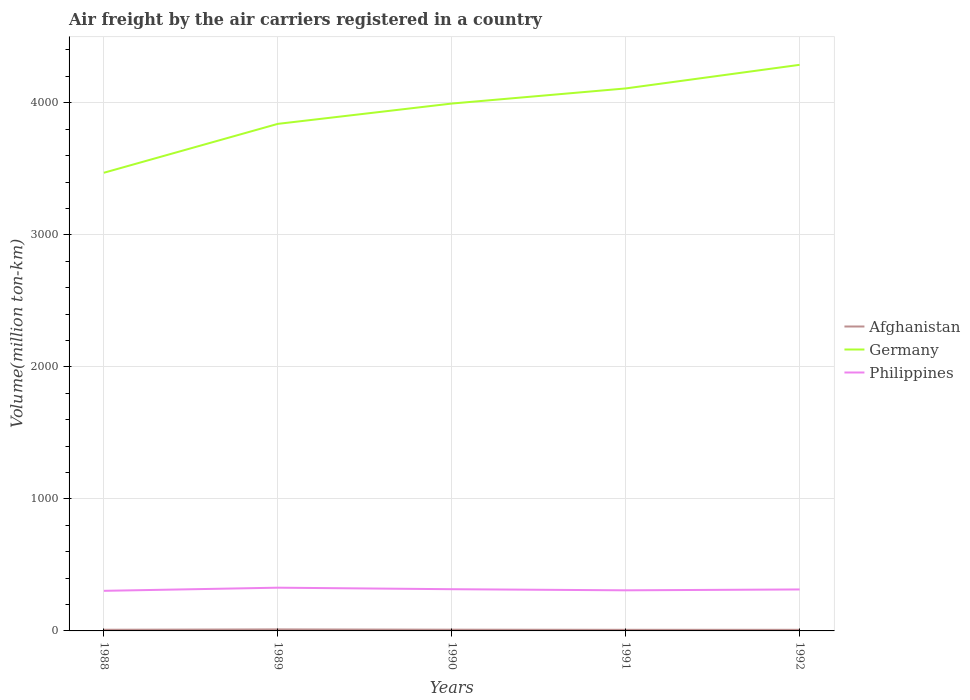How many different coloured lines are there?
Keep it short and to the point. 3. Does the line corresponding to Afghanistan intersect with the line corresponding to Philippines?
Give a very brief answer. No. Is the number of lines equal to the number of legend labels?
Your answer should be very brief. Yes. Across all years, what is the maximum volume of the air carriers in Afghanistan?
Your answer should be very brief. 8.4. In which year was the volume of the air carriers in Germany maximum?
Your answer should be compact. 1988. What is the total volume of the air carriers in Afghanistan in the graph?
Keep it short and to the point. 0. What is the difference between the highest and the second highest volume of the air carriers in Philippines?
Provide a succinct answer. 23.7. Is the volume of the air carriers in Germany strictly greater than the volume of the air carriers in Philippines over the years?
Your response must be concise. No. What is the difference between two consecutive major ticks on the Y-axis?
Your response must be concise. 1000. Does the graph contain any zero values?
Give a very brief answer. No. Where does the legend appear in the graph?
Offer a very short reply. Center right. How many legend labels are there?
Offer a very short reply. 3. What is the title of the graph?
Make the answer very short. Air freight by the air carriers registered in a country. What is the label or title of the Y-axis?
Your response must be concise. Volume(million ton-km). What is the Volume(million ton-km) of Afghanistan in 1988?
Your response must be concise. 8.8. What is the Volume(million ton-km) in Germany in 1988?
Your response must be concise. 3470. What is the Volume(million ton-km) in Philippines in 1988?
Keep it short and to the point. 303.7. What is the Volume(million ton-km) of Germany in 1989?
Your response must be concise. 3840.3. What is the Volume(million ton-km) of Philippines in 1989?
Offer a terse response. 327.4. What is the Volume(million ton-km) in Afghanistan in 1990?
Offer a very short reply. 9.4. What is the Volume(million ton-km) in Germany in 1990?
Your answer should be compact. 3994.2. What is the Volume(million ton-km) of Philippines in 1990?
Your answer should be very brief. 316. What is the Volume(million ton-km) of Afghanistan in 1991?
Your response must be concise. 8.4. What is the Volume(million ton-km) of Germany in 1991?
Keep it short and to the point. 4108.7. What is the Volume(million ton-km) in Philippines in 1991?
Your response must be concise. 307.6. What is the Volume(million ton-km) of Afghanistan in 1992?
Ensure brevity in your answer.  8.4. What is the Volume(million ton-km) in Germany in 1992?
Offer a very short reply. 4287.5. What is the Volume(million ton-km) in Philippines in 1992?
Offer a terse response. 314.1. Across all years, what is the maximum Volume(million ton-km) in Germany?
Offer a terse response. 4287.5. Across all years, what is the maximum Volume(million ton-km) of Philippines?
Offer a very short reply. 327.4. Across all years, what is the minimum Volume(million ton-km) of Afghanistan?
Give a very brief answer. 8.4. Across all years, what is the minimum Volume(million ton-km) in Germany?
Your answer should be compact. 3470. Across all years, what is the minimum Volume(million ton-km) of Philippines?
Your response must be concise. 303.7. What is the total Volume(million ton-km) of Afghanistan in the graph?
Ensure brevity in your answer.  46.5. What is the total Volume(million ton-km) of Germany in the graph?
Offer a terse response. 1.97e+04. What is the total Volume(million ton-km) of Philippines in the graph?
Make the answer very short. 1568.8. What is the difference between the Volume(million ton-km) of Afghanistan in 1988 and that in 1989?
Your answer should be very brief. -2.7. What is the difference between the Volume(million ton-km) of Germany in 1988 and that in 1989?
Offer a terse response. -370.3. What is the difference between the Volume(million ton-km) of Philippines in 1988 and that in 1989?
Offer a terse response. -23.7. What is the difference between the Volume(million ton-km) of Germany in 1988 and that in 1990?
Make the answer very short. -524.2. What is the difference between the Volume(million ton-km) of Philippines in 1988 and that in 1990?
Give a very brief answer. -12.3. What is the difference between the Volume(million ton-km) in Germany in 1988 and that in 1991?
Your response must be concise. -638.7. What is the difference between the Volume(million ton-km) of Germany in 1988 and that in 1992?
Keep it short and to the point. -817.5. What is the difference between the Volume(million ton-km) of Philippines in 1988 and that in 1992?
Keep it short and to the point. -10.4. What is the difference between the Volume(million ton-km) of Afghanistan in 1989 and that in 1990?
Your answer should be very brief. 2.1. What is the difference between the Volume(million ton-km) in Germany in 1989 and that in 1990?
Your response must be concise. -153.9. What is the difference between the Volume(million ton-km) of Germany in 1989 and that in 1991?
Your response must be concise. -268.4. What is the difference between the Volume(million ton-km) of Philippines in 1989 and that in 1991?
Keep it short and to the point. 19.8. What is the difference between the Volume(million ton-km) of Afghanistan in 1989 and that in 1992?
Keep it short and to the point. 3.1. What is the difference between the Volume(million ton-km) in Germany in 1989 and that in 1992?
Provide a short and direct response. -447.2. What is the difference between the Volume(million ton-km) in Philippines in 1989 and that in 1992?
Keep it short and to the point. 13.3. What is the difference between the Volume(million ton-km) of Germany in 1990 and that in 1991?
Your answer should be very brief. -114.5. What is the difference between the Volume(million ton-km) of Afghanistan in 1990 and that in 1992?
Provide a succinct answer. 1. What is the difference between the Volume(million ton-km) of Germany in 1990 and that in 1992?
Your answer should be very brief. -293.3. What is the difference between the Volume(million ton-km) in Philippines in 1990 and that in 1992?
Your answer should be compact. 1.9. What is the difference between the Volume(million ton-km) in Germany in 1991 and that in 1992?
Make the answer very short. -178.8. What is the difference between the Volume(million ton-km) of Afghanistan in 1988 and the Volume(million ton-km) of Germany in 1989?
Offer a very short reply. -3831.5. What is the difference between the Volume(million ton-km) in Afghanistan in 1988 and the Volume(million ton-km) in Philippines in 1989?
Make the answer very short. -318.6. What is the difference between the Volume(million ton-km) in Germany in 1988 and the Volume(million ton-km) in Philippines in 1989?
Offer a terse response. 3142.6. What is the difference between the Volume(million ton-km) in Afghanistan in 1988 and the Volume(million ton-km) in Germany in 1990?
Your answer should be very brief. -3985.4. What is the difference between the Volume(million ton-km) of Afghanistan in 1988 and the Volume(million ton-km) of Philippines in 1990?
Your answer should be compact. -307.2. What is the difference between the Volume(million ton-km) in Germany in 1988 and the Volume(million ton-km) in Philippines in 1990?
Ensure brevity in your answer.  3154. What is the difference between the Volume(million ton-km) of Afghanistan in 1988 and the Volume(million ton-km) of Germany in 1991?
Ensure brevity in your answer.  -4099.9. What is the difference between the Volume(million ton-km) in Afghanistan in 1988 and the Volume(million ton-km) in Philippines in 1991?
Your answer should be very brief. -298.8. What is the difference between the Volume(million ton-km) in Germany in 1988 and the Volume(million ton-km) in Philippines in 1991?
Offer a very short reply. 3162.4. What is the difference between the Volume(million ton-km) of Afghanistan in 1988 and the Volume(million ton-km) of Germany in 1992?
Offer a very short reply. -4278.7. What is the difference between the Volume(million ton-km) of Afghanistan in 1988 and the Volume(million ton-km) of Philippines in 1992?
Offer a terse response. -305.3. What is the difference between the Volume(million ton-km) in Germany in 1988 and the Volume(million ton-km) in Philippines in 1992?
Your response must be concise. 3155.9. What is the difference between the Volume(million ton-km) in Afghanistan in 1989 and the Volume(million ton-km) in Germany in 1990?
Make the answer very short. -3982.7. What is the difference between the Volume(million ton-km) in Afghanistan in 1989 and the Volume(million ton-km) in Philippines in 1990?
Your response must be concise. -304.5. What is the difference between the Volume(million ton-km) of Germany in 1989 and the Volume(million ton-km) of Philippines in 1990?
Your response must be concise. 3524.3. What is the difference between the Volume(million ton-km) in Afghanistan in 1989 and the Volume(million ton-km) in Germany in 1991?
Provide a succinct answer. -4097.2. What is the difference between the Volume(million ton-km) of Afghanistan in 1989 and the Volume(million ton-km) of Philippines in 1991?
Your response must be concise. -296.1. What is the difference between the Volume(million ton-km) of Germany in 1989 and the Volume(million ton-km) of Philippines in 1991?
Your response must be concise. 3532.7. What is the difference between the Volume(million ton-km) of Afghanistan in 1989 and the Volume(million ton-km) of Germany in 1992?
Your answer should be very brief. -4276. What is the difference between the Volume(million ton-km) of Afghanistan in 1989 and the Volume(million ton-km) of Philippines in 1992?
Ensure brevity in your answer.  -302.6. What is the difference between the Volume(million ton-km) of Germany in 1989 and the Volume(million ton-km) of Philippines in 1992?
Ensure brevity in your answer.  3526.2. What is the difference between the Volume(million ton-km) in Afghanistan in 1990 and the Volume(million ton-km) in Germany in 1991?
Provide a short and direct response. -4099.3. What is the difference between the Volume(million ton-km) in Afghanistan in 1990 and the Volume(million ton-km) in Philippines in 1991?
Provide a short and direct response. -298.2. What is the difference between the Volume(million ton-km) of Germany in 1990 and the Volume(million ton-km) of Philippines in 1991?
Your answer should be very brief. 3686.6. What is the difference between the Volume(million ton-km) of Afghanistan in 1990 and the Volume(million ton-km) of Germany in 1992?
Ensure brevity in your answer.  -4278.1. What is the difference between the Volume(million ton-km) of Afghanistan in 1990 and the Volume(million ton-km) of Philippines in 1992?
Offer a very short reply. -304.7. What is the difference between the Volume(million ton-km) of Germany in 1990 and the Volume(million ton-km) of Philippines in 1992?
Your answer should be compact. 3680.1. What is the difference between the Volume(million ton-km) in Afghanistan in 1991 and the Volume(million ton-km) in Germany in 1992?
Provide a short and direct response. -4279.1. What is the difference between the Volume(million ton-km) of Afghanistan in 1991 and the Volume(million ton-km) of Philippines in 1992?
Offer a terse response. -305.7. What is the difference between the Volume(million ton-km) of Germany in 1991 and the Volume(million ton-km) of Philippines in 1992?
Provide a short and direct response. 3794.6. What is the average Volume(million ton-km) in Germany per year?
Your answer should be compact. 3940.14. What is the average Volume(million ton-km) of Philippines per year?
Offer a very short reply. 313.76. In the year 1988, what is the difference between the Volume(million ton-km) in Afghanistan and Volume(million ton-km) in Germany?
Offer a very short reply. -3461.2. In the year 1988, what is the difference between the Volume(million ton-km) of Afghanistan and Volume(million ton-km) of Philippines?
Keep it short and to the point. -294.9. In the year 1988, what is the difference between the Volume(million ton-km) of Germany and Volume(million ton-km) of Philippines?
Your answer should be compact. 3166.3. In the year 1989, what is the difference between the Volume(million ton-km) in Afghanistan and Volume(million ton-km) in Germany?
Keep it short and to the point. -3828.8. In the year 1989, what is the difference between the Volume(million ton-km) of Afghanistan and Volume(million ton-km) of Philippines?
Provide a succinct answer. -315.9. In the year 1989, what is the difference between the Volume(million ton-km) of Germany and Volume(million ton-km) of Philippines?
Give a very brief answer. 3512.9. In the year 1990, what is the difference between the Volume(million ton-km) of Afghanistan and Volume(million ton-km) of Germany?
Keep it short and to the point. -3984.8. In the year 1990, what is the difference between the Volume(million ton-km) of Afghanistan and Volume(million ton-km) of Philippines?
Your answer should be compact. -306.6. In the year 1990, what is the difference between the Volume(million ton-km) in Germany and Volume(million ton-km) in Philippines?
Ensure brevity in your answer.  3678.2. In the year 1991, what is the difference between the Volume(million ton-km) in Afghanistan and Volume(million ton-km) in Germany?
Keep it short and to the point. -4100.3. In the year 1991, what is the difference between the Volume(million ton-km) in Afghanistan and Volume(million ton-km) in Philippines?
Your response must be concise. -299.2. In the year 1991, what is the difference between the Volume(million ton-km) in Germany and Volume(million ton-km) in Philippines?
Ensure brevity in your answer.  3801.1. In the year 1992, what is the difference between the Volume(million ton-km) of Afghanistan and Volume(million ton-km) of Germany?
Make the answer very short. -4279.1. In the year 1992, what is the difference between the Volume(million ton-km) of Afghanistan and Volume(million ton-km) of Philippines?
Provide a short and direct response. -305.7. In the year 1992, what is the difference between the Volume(million ton-km) of Germany and Volume(million ton-km) of Philippines?
Keep it short and to the point. 3973.4. What is the ratio of the Volume(million ton-km) of Afghanistan in 1988 to that in 1989?
Give a very brief answer. 0.77. What is the ratio of the Volume(million ton-km) of Germany in 1988 to that in 1989?
Your response must be concise. 0.9. What is the ratio of the Volume(million ton-km) of Philippines in 1988 to that in 1989?
Provide a succinct answer. 0.93. What is the ratio of the Volume(million ton-km) in Afghanistan in 1988 to that in 1990?
Provide a succinct answer. 0.94. What is the ratio of the Volume(million ton-km) of Germany in 1988 to that in 1990?
Offer a very short reply. 0.87. What is the ratio of the Volume(million ton-km) in Philippines in 1988 to that in 1990?
Provide a succinct answer. 0.96. What is the ratio of the Volume(million ton-km) in Afghanistan in 1988 to that in 1991?
Keep it short and to the point. 1.05. What is the ratio of the Volume(million ton-km) of Germany in 1988 to that in 1991?
Ensure brevity in your answer.  0.84. What is the ratio of the Volume(million ton-km) in Philippines in 1988 to that in 1991?
Offer a very short reply. 0.99. What is the ratio of the Volume(million ton-km) of Afghanistan in 1988 to that in 1992?
Provide a succinct answer. 1.05. What is the ratio of the Volume(million ton-km) in Germany in 1988 to that in 1992?
Provide a succinct answer. 0.81. What is the ratio of the Volume(million ton-km) of Philippines in 1988 to that in 1992?
Give a very brief answer. 0.97. What is the ratio of the Volume(million ton-km) in Afghanistan in 1989 to that in 1990?
Make the answer very short. 1.22. What is the ratio of the Volume(million ton-km) of Germany in 1989 to that in 1990?
Offer a terse response. 0.96. What is the ratio of the Volume(million ton-km) of Philippines in 1989 to that in 1990?
Ensure brevity in your answer.  1.04. What is the ratio of the Volume(million ton-km) in Afghanistan in 1989 to that in 1991?
Provide a succinct answer. 1.37. What is the ratio of the Volume(million ton-km) of Germany in 1989 to that in 1991?
Ensure brevity in your answer.  0.93. What is the ratio of the Volume(million ton-km) of Philippines in 1989 to that in 1991?
Your response must be concise. 1.06. What is the ratio of the Volume(million ton-km) in Afghanistan in 1989 to that in 1992?
Provide a short and direct response. 1.37. What is the ratio of the Volume(million ton-km) in Germany in 1989 to that in 1992?
Ensure brevity in your answer.  0.9. What is the ratio of the Volume(million ton-km) of Philippines in 1989 to that in 1992?
Offer a very short reply. 1.04. What is the ratio of the Volume(million ton-km) of Afghanistan in 1990 to that in 1991?
Your answer should be compact. 1.12. What is the ratio of the Volume(million ton-km) in Germany in 1990 to that in 1991?
Your response must be concise. 0.97. What is the ratio of the Volume(million ton-km) of Philippines in 1990 to that in 1991?
Provide a succinct answer. 1.03. What is the ratio of the Volume(million ton-km) in Afghanistan in 1990 to that in 1992?
Your answer should be very brief. 1.12. What is the ratio of the Volume(million ton-km) of Germany in 1990 to that in 1992?
Ensure brevity in your answer.  0.93. What is the ratio of the Volume(million ton-km) of Philippines in 1990 to that in 1992?
Provide a succinct answer. 1.01. What is the ratio of the Volume(million ton-km) in Afghanistan in 1991 to that in 1992?
Provide a succinct answer. 1. What is the ratio of the Volume(million ton-km) in Philippines in 1991 to that in 1992?
Make the answer very short. 0.98. What is the difference between the highest and the second highest Volume(million ton-km) of Afghanistan?
Ensure brevity in your answer.  2.1. What is the difference between the highest and the second highest Volume(million ton-km) of Germany?
Your answer should be very brief. 178.8. What is the difference between the highest and the second highest Volume(million ton-km) of Philippines?
Keep it short and to the point. 11.4. What is the difference between the highest and the lowest Volume(million ton-km) in Afghanistan?
Your answer should be compact. 3.1. What is the difference between the highest and the lowest Volume(million ton-km) in Germany?
Ensure brevity in your answer.  817.5. What is the difference between the highest and the lowest Volume(million ton-km) of Philippines?
Offer a terse response. 23.7. 